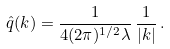Convert formula to latex. <formula><loc_0><loc_0><loc_500><loc_500>\hat { q } ( k ) = \frac { 1 } { 4 ( 2 \pi ) ^ { 1 / 2 } \lambda } \, \frac { 1 } { | k | } \, .</formula> 